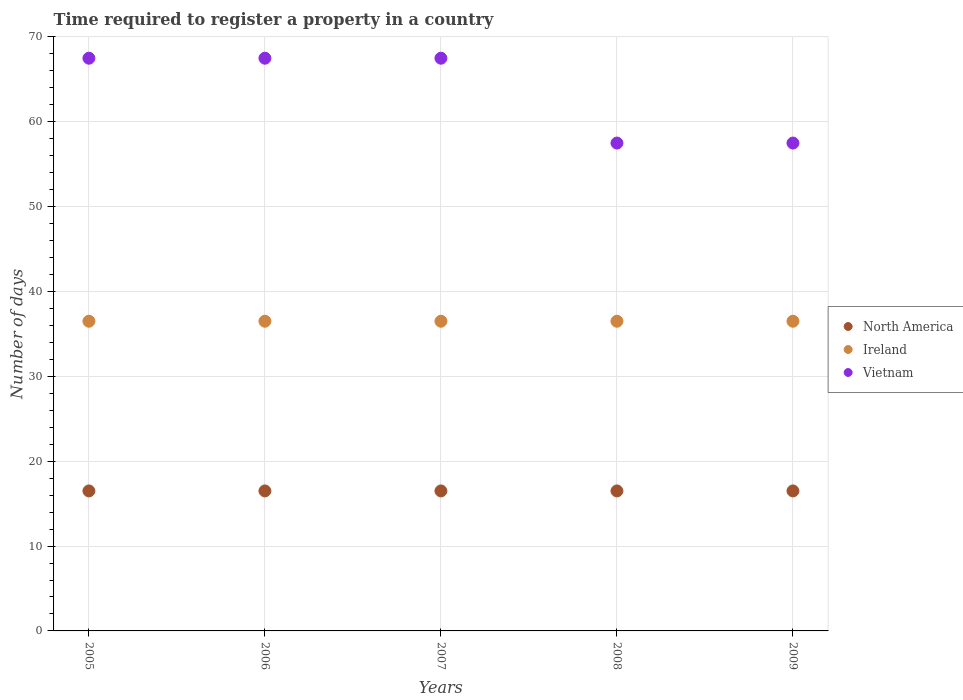Is the number of dotlines equal to the number of legend labels?
Offer a terse response. Yes. What is the number of days required to register a property in Vietnam in 2006?
Keep it short and to the point. 67.5. Across all years, what is the maximum number of days required to register a property in Ireland?
Keep it short and to the point. 36.5. What is the total number of days required to register a property in North America in the graph?
Your answer should be compact. 82.5. What is the difference between the number of days required to register a property in Vietnam in 2007 and that in 2009?
Your answer should be very brief. 10. What is the average number of days required to register a property in Ireland per year?
Your response must be concise. 36.5. In the year 2007, what is the difference between the number of days required to register a property in Ireland and number of days required to register a property in Vietnam?
Your response must be concise. -31. What is the ratio of the number of days required to register a property in Ireland in 2005 to that in 2007?
Offer a terse response. 1. Is the sum of the number of days required to register a property in Vietnam in 2007 and 2008 greater than the maximum number of days required to register a property in Ireland across all years?
Give a very brief answer. Yes. Is the number of days required to register a property in Ireland strictly less than the number of days required to register a property in North America over the years?
Your answer should be compact. No. What is the difference between two consecutive major ticks on the Y-axis?
Give a very brief answer. 10. Are the values on the major ticks of Y-axis written in scientific E-notation?
Your answer should be very brief. No. Does the graph contain grids?
Provide a succinct answer. Yes. Where does the legend appear in the graph?
Offer a terse response. Center right. How are the legend labels stacked?
Offer a terse response. Vertical. What is the title of the graph?
Offer a terse response. Time required to register a property in a country. What is the label or title of the Y-axis?
Ensure brevity in your answer.  Number of days. What is the Number of days of Ireland in 2005?
Your response must be concise. 36.5. What is the Number of days of Vietnam in 2005?
Make the answer very short. 67.5. What is the Number of days in Ireland in 2006?
Your answer should be very brief. 36.5. What is the Number of days of Vietnam in 2006?
Offer a very short reply. 67.5. What is the Number of days in Ireland in 2007?
Provide a succinct answer. 36.5. What is the Number of days of Vietnam in 2007?
Provide a short and direct response. 67.5. What is the Number of days in Ireland in 2008?
Offer a very short reply. 36.5. What is the Number of days in Vietnam in 2008?
Offer a very short reply. 57.5. What is the Number of days of North America in 2009?
Offer a very short reply. 16.5. What is the Number of days of Ireland in 2009?
Offer a very short reply. 36.5. What is the Number of days in Vietnam in 2009?
Your answer should be compact. 57.5. Across all years, what is the maximum Number of days in Ireland?
Provide a short and direct response. 36.5. Across all years, what is the maximum Number of days of Vietnam?
Ensure brevity in your answer.  67.5. Across all years, what is the minimum Number of days in Ireland?
Offer a terse response. 36.5. Across all years, what is the minimum Number of days in Vietnam?
Your answer should be compact. 57.5. What is the total Number of days of North America in the graph?
Provide a short and direct response. 82.5. What is the total Number of days of Ireland in the graph?
Your answer should be very brief. 182.5. What is the total Number of days of Vietnam in the graph?
Provide a short and direct response. 317.5. What is the difference between the Number of days of Ireland in 2005 and that in 2006?
Provide a short and direct response. 0. What is the difference between the Number of days in North America in 2005 and that in 2007?
Provide a short and direct response. 0. What is the difference between the Number of days in Ireland in 2005 and that in 2007?
Provide a succinct answer. 0. What is the difference between the Number of days in North America in 2005 and that in 2008?
Offer a very short reply. 0. What is the difference between the Number of days in Ireland in 2005 and that in 2008?
Your response must be concise. 0. What is the difference between the Number of days in Ireland in 2006 and that in 2007?
Your answer should be compact. 0. What is the difference between the Number of days in Vietnam in 2006 and that in 2007?
Provide a succinct answer. 0. What is the difference between the Number of days of North America in 2006 and that in 2008?
Ensure brevity in your answer.  0. What is the difference between the Number of days in Ireland in 2007 and that in 2008?
Your answer should be very brief. 0. What is the difference between the Number of days of Vietnam in 2007 and that in 2009?
Keep it short and to the point. 10. What is the difference between the Number of days in Ireland in 2008 and that in 2009?
Give a very brief answer. 0. What is the difference between the Number of days in Vietnam in 2008 and that in 2009?
Ensure brevity in your answer.  0. What is the difference between the Number of days in North America in 2005 and the Number of days in Vietnam in 2006?
Give a very brief answer. -51. What is the difference between the Number of days in Ireland in 2005 and the Number of days in Vietnam in 2006?
Make the answer very short. -31. What is the difference between the Number of days of North America in 2005 and the Number of days of Vietnam in 2007?
Give a very brief answer. -51. What is the difference between the Number of days in Ireland in 2005 and the Number of days in Vietnam in 2007?
Provide a succinct answer. -31. What is the difference between the Number of days in North America in 2005 and the Number of days in Vietnam in 2008?
Your response must be concise. -41. What is the difference between the Number of days of North America in 2005 and the Number of days of Ireland in 2009?
Give a very brief answer. -20. What is the difference between the Number of days in North America in 2005 and the Number of days in Vietnam in 2009?
Your answer should be compact. -41. What is the difference between the Number of days of North America in 2006 and the Number of days of Vietnam in 2007?
Provide a succinct answer. -51. What is the difference between the Number of days in Ireland in 2006 and the Number of days in Vietnam in 2007?
Offer a terse response. -31. What is the difference between the Number of days of North America in 2006 and the Number of days of Vietnam in 2008?
Offer a very short reply. -41. What is the difference between the Number of days in Ireland in 2006 and the Number of days in Vietnam in 2008?
Your response must be concise. -21. What is the difference between the Number of days in North America in 2006 and the Number of days in Vietnam in 2009?
Provide a short and direct response. -41. What is the difference between the Number of days of Ireland in 2006 and the Number of days of Vietnam in 2009?
Provide a short and direct response. -21. What is the difference between the Number of days in North America in 2007 and the Number of days in Ireland in 2008?
Your response must be concise. -20. What is the difference between the Number of days in North America in 2007 and the Number of days in Vietnam in 2008?
Your response must be concise. -41. What is the difference between the Number of days of North America in 2007 and the Number of days of Vietnam in 2009?
Offer a very short reply. -41. What is the difference between the Number of days of North America in 2008 and the Number of days of Ireland in 2009?
Your answer should be compact. -20. What is the difference between the Number of days of North America in 2008 and the Number of days of Vietnam in 2009?
Offer a terse response. -41. What is the average Number of days in North America per year?
Your answer should be compact. 16.5. What is the average Number of days in Ireland per year?
Make the answer very short. 36.5. What is the average Number of days in Vietnam per year?
Make the answer very short. 63.5. In the year 2005, what is the difference between the Number of days in North America and Number of days in Ireland?
Your answer should be compact. -20. In the year 2005, what is the difference between the Number of days in North America and Number of days in Vietnam?
Give a very brief answer. -51. In the year 2005, what is the difference between the Number of days in Ireland and Number of days in Vietnam?
Give a very brief answer. -31. In the year 2006, what is the difference between the Number of days of North America and Number of days of Vietnam?
Offer a very short reply. -51. In the year 2006, what is the difference between the Number of days in Ireland and Number of days in Vietnam?
Make the answer very short. -31. In the year 2007, what is the difference between the Number of days of North America and Number of days of Vietnam?
Provide a succinct answer. -51. In the year 2007, what is the difference between the Number of days of Ireland and Number of days of Vietnam?
Keep it short and to the point. -31. In the year 2008, what is the difference between the Number of days of North America and Number of days of Ireland?
Provide a short and direct response. -20. In the year 2008, what is the difference between the Number of days of North America and Number of days of Vietnam?
Offer a terse response. -41. In the year 2008, what is the difference between the Number of days in Ireland and Number of days in Vietnam?
Keep it short and to the point. -21. In the year 2009, what is the difference between the Number of days in North America and Number of days in Ireland?
Offer a very short reply. -20. In the year 2009, what is the difference between the Number of days of North America and Number of days of Vietnam?
Ensure brevity in your answer.  -41. What is the ratio of the Number of days of Ireland in 2005 to that in 2007?
Give a very brief answer. 1. What is the ratio of the Number of days of Vietnam in 2005 to that in 2007?
Make the answer very short. 1. What is the ratio of the Number of days of North America in 2005 to that in 2008?
Give a very brief answer. 1. What is the ratio of the Number of days in Vietnam in 2005 to that in 2008?
Ensure brevity in your answer.  1.17. What is the ratio of the Number of days of Ireland in 2005 to that in 2009?
Offer a terse response. 1. What is the ratio of the Number of days of Vietnam in 2005 to that in 2009?
Your answer should be very brief. 1.17. What is the ratio of the Number of days in North America in 2006 to that in 2008?
Your answer should be very brief. 1. What is the ratio of the Number of days in Ireland in 2006 to that in 2008?
Provide a succinct answer. 1. What is the ratio of the Number of days of Vietnam in 2006 to that in 2008?
Provide a succinct answer. 1.17. What is the ratio of the Number of days in North America in 2006 to that in 2009?
Keep it short and to the point. 1. What is the ratio of the Number of days in Ireland in 2006 to that in 2009?
Your answer should be very brief. 1. What is the ratio of the Number of days of Vietnam in 2006 to that in 2009?
Keep it short and to the point. 1.17. What is the ratio of the Number of days in Vietnam in 2007 to that in 2008?
Provide a succinct answer. 1.17. What is the ratio of the Number of days in North America in 2007 to that in 2009?
Provide a succinct answer. 1. What is the ratio of the Number of days of Ireland in 2007 to that in 2009?
Offer a terse response. 1. What is the ratio of the Number of days in Vietnam in 2007 to that in 2009?
Keep it short and to the point. 1.17. What is the ratio of the Number of days in North America in 2008 to that in 2009?
Your answer should be very brief. 1. What is the ratio of the Number of days in Ireland in 2008 to that in 2009?
Your response must be concise. 1. What is the ratio of the Number of days of Vietnam in 2008 to that in 2009?
Provide a short and direct response. 1. What is the difference between the highest and the second highest Number of days of Vietnam?
Make the answer very short. 0. What is the difference between the highest and the lowest Number of days in North America?
Your response must be concise. 0. What is the difference between the highest and the lowest Number of days of Vietnam?
Offer a very short reply. 10. 